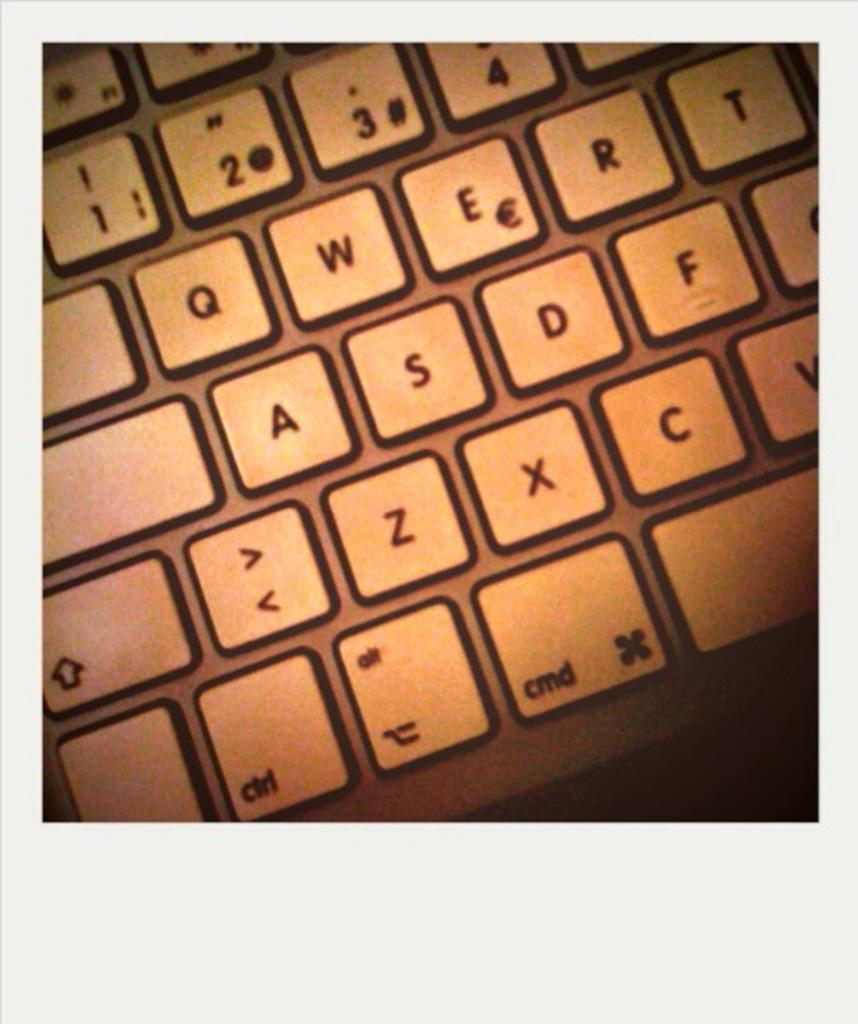<image>
Share a concise interpretation of the image provided. a close up of a key board with keys like CMD and Z 